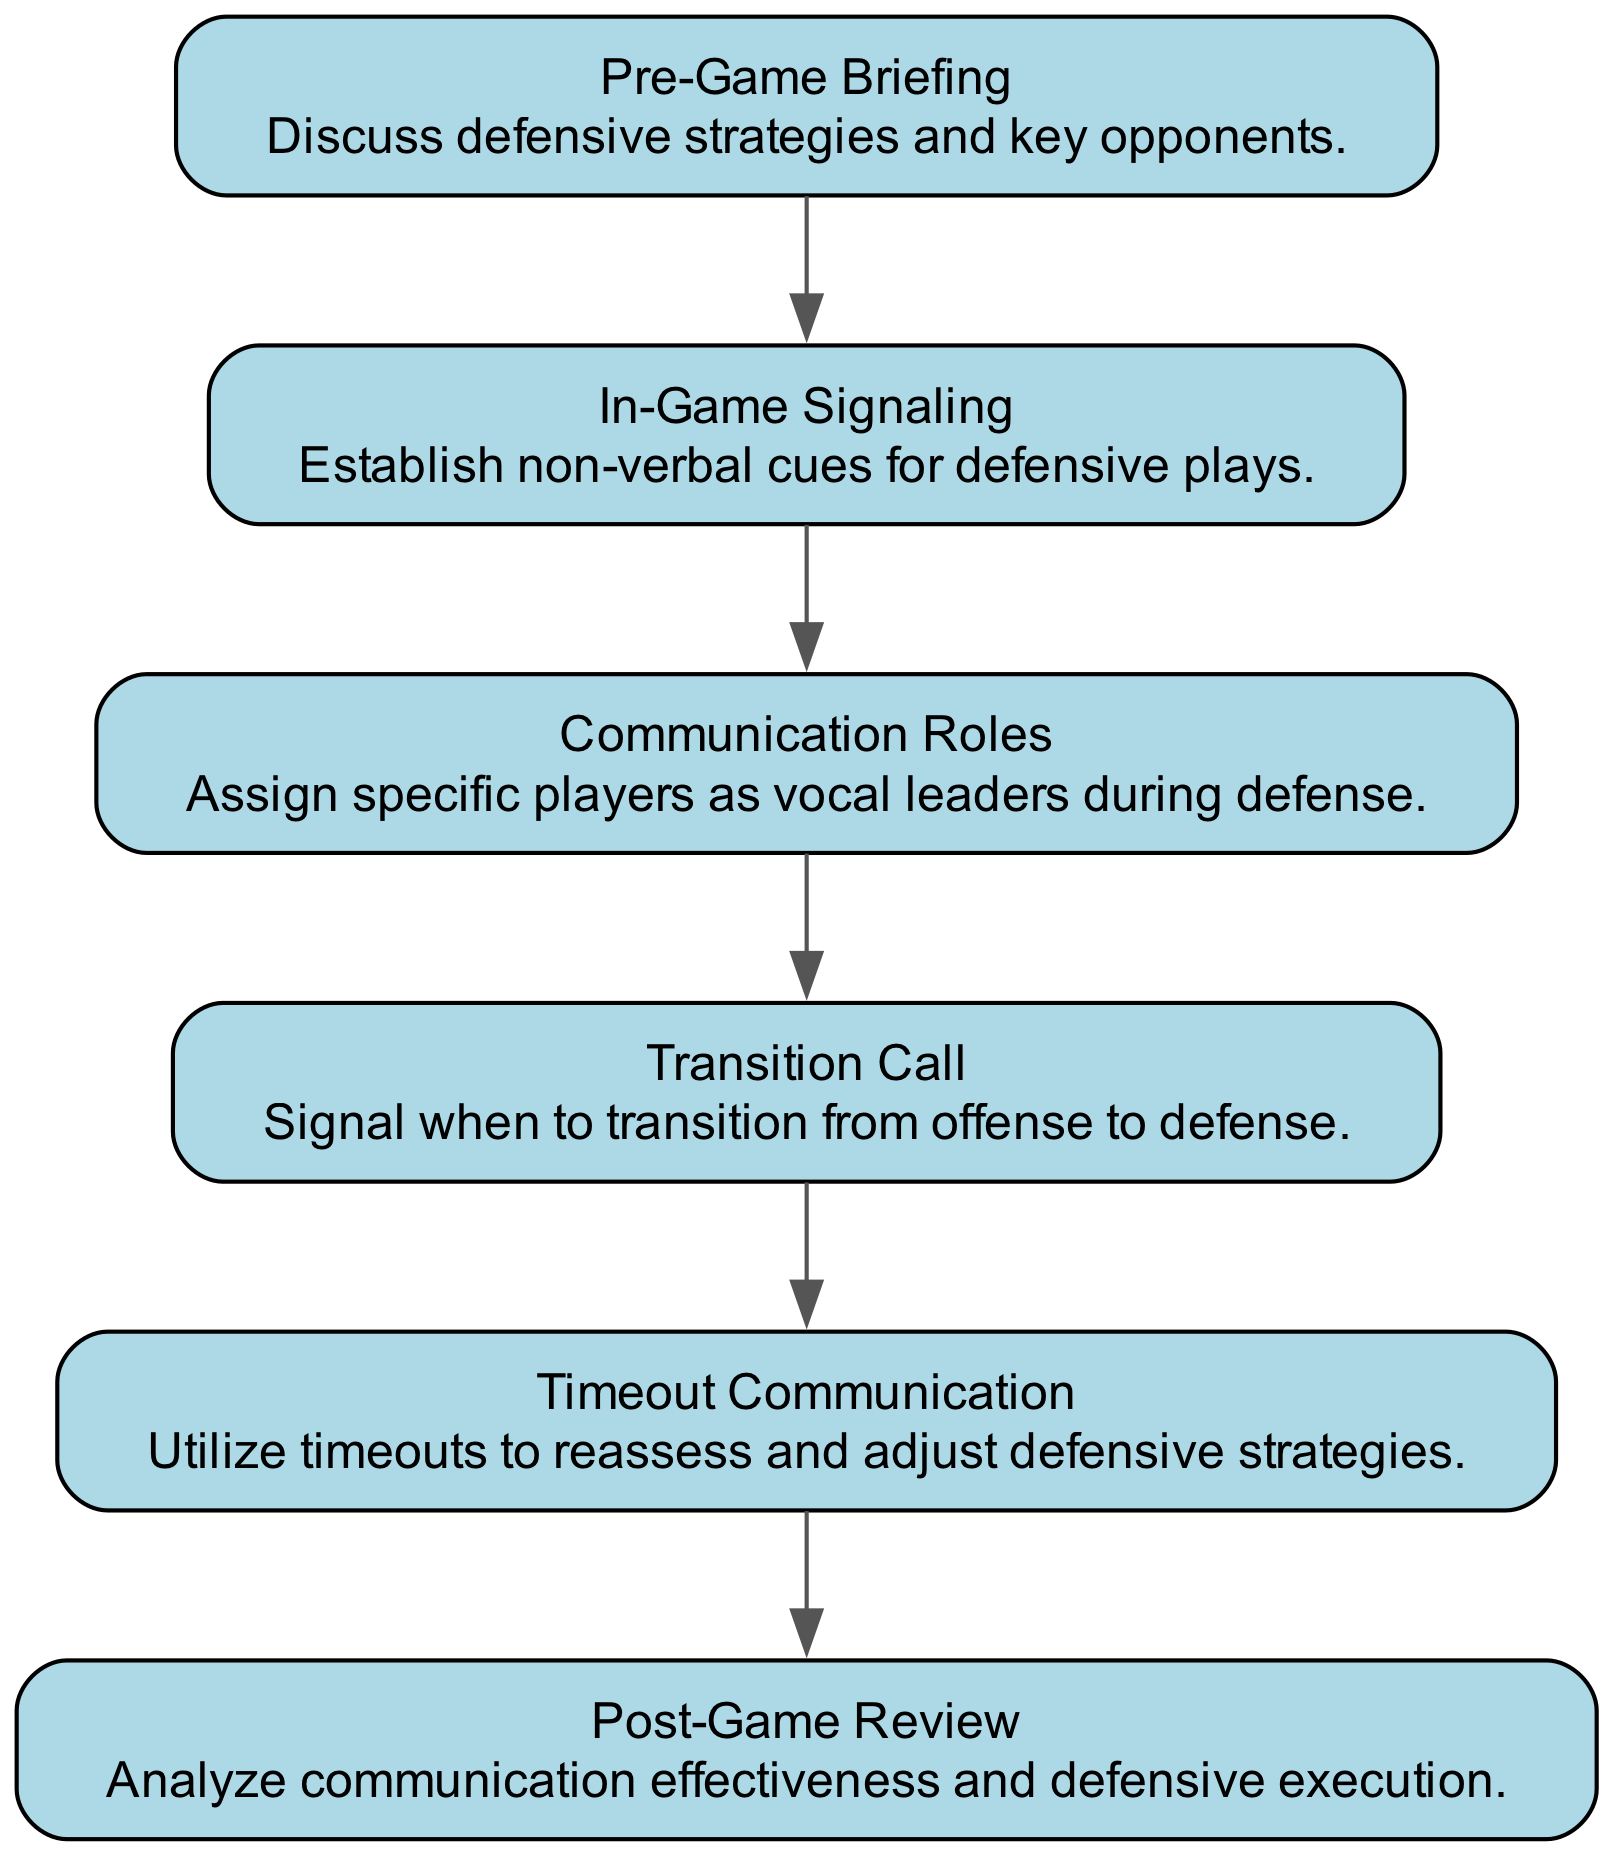What is the first step in the communication protocol? The first element in the flow chart is "Pre-Game Briefing". It is the starting point that sets the foundation for further communication protocols.
Answer: Pre-Game Briefing How many elements are in the diagram? The diagram contains six elements, as counted in the provided data structure. Each element represents a key part of the defensive communication protocol.
Answer: 6 What occurs after "In-Game Signaling"? Following "In-Game Signaling", the next element in the flow is "Communication Roles". This indicates a flow of actions in which in-game signaling leads to assigning roles.
Answer: Communication Roles What is the last step in the communication protocol? The final element in the flow chart is "Post-Game Review", which concludes the sequence of communication protocols. It serves as a reflection of the game.
Answer: Post-Game Review Which step involves analyzing communication effectiveness? The step that focuses on analyzing communication effectiveness is "Post-Game Review", as indicated at the end of the sequence, where teams reflect on their performance.
Answer: Post-Game Review What type of communication occurs during timeouts? The type of communication that takes place during timeouts is specifically outlined as "Timeout Communication", meant to reassess and adjust strategies.
Answer: Timeout Communication How do teams signal a transition from offense to defense? Teams signal a transition from offense to defense using the step labeled "Transition Call". This indicates when players should switch their focus.
Answer: Transition Call What is the relationship between "Pre-Game Briefing" and "In-Game Signaling"? The relationship is sequential; "In-Game Signaling" follows directly after "Pre-Game Briefing", indicating that pre-game discussions lead to in-game actions.
Answer: Sequential Which element is served by vocal leaders during the game? The element that utilizes vocal leaders during the game is "Communication Roles", which assigns specific leaders for effective communication on defense.
Answer: Communication Roles 